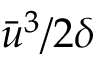Convert formula to latex. <formula><loc_0><loc_0><loc_500><loc_500>\bar { u } ^ { 3 } / 2 \delta</formula> 